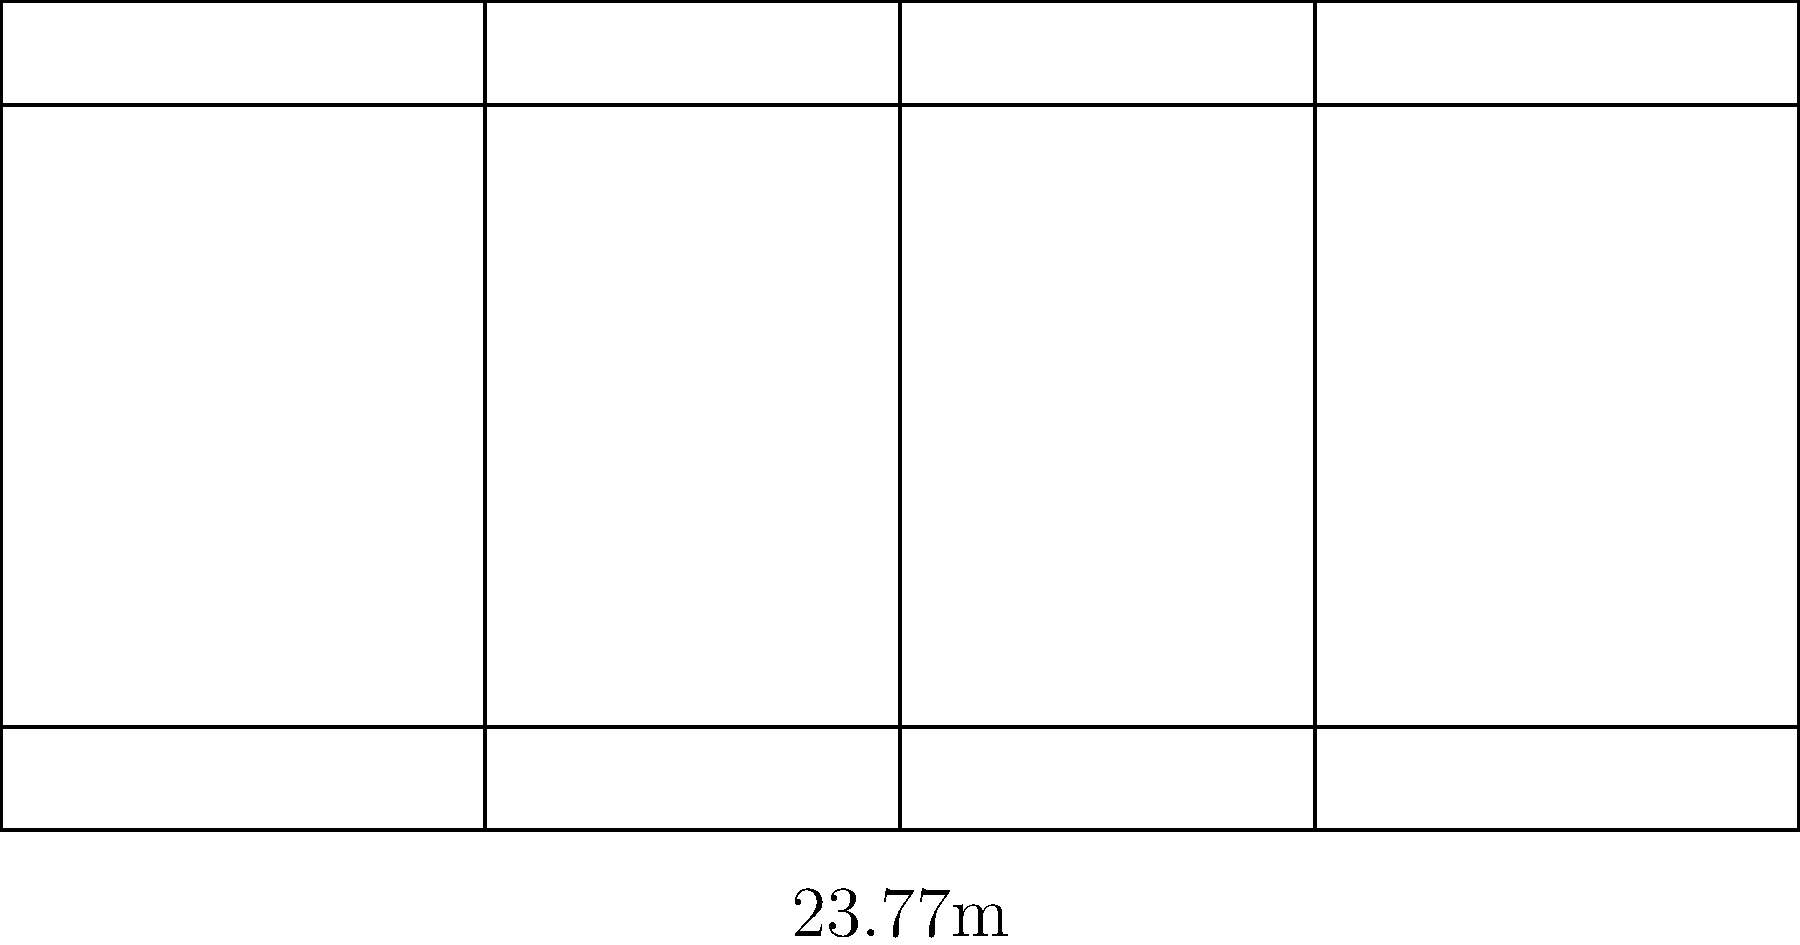In a professional tennis match, what is the total area of the two service boxes combined? To calculate the total area of the two service boxes, we need to follow these steps:

1. Identify the dimensions of a single service box:
   - Width: Half of the singles court width = $10.97 \text{ m} / 2 = 5.485 \text{ m}$
   - Length: From the service line to the net = $6.40 \text{ m}$

2. Calculate the area of one service box:
   Area = width × length
   $A_1 = 5.485 \text{ m} \times 6.40 \text{ m} = 35.104 \text{ m}^2$

3. Since there are two identical service boxes (one on each side of the net), multiply the area of one box by 2:
   Total area = $2 \times A_1$
   $A_{\text{total}} = 2 \times 35.104 \text{ m}^2 = 70.208 \text{ m}^2$

Therefore, the total area of the two service boxes combined is $70.208 \text{ m}^2$.
Answer: $70.208 \text{ m}^2$ 